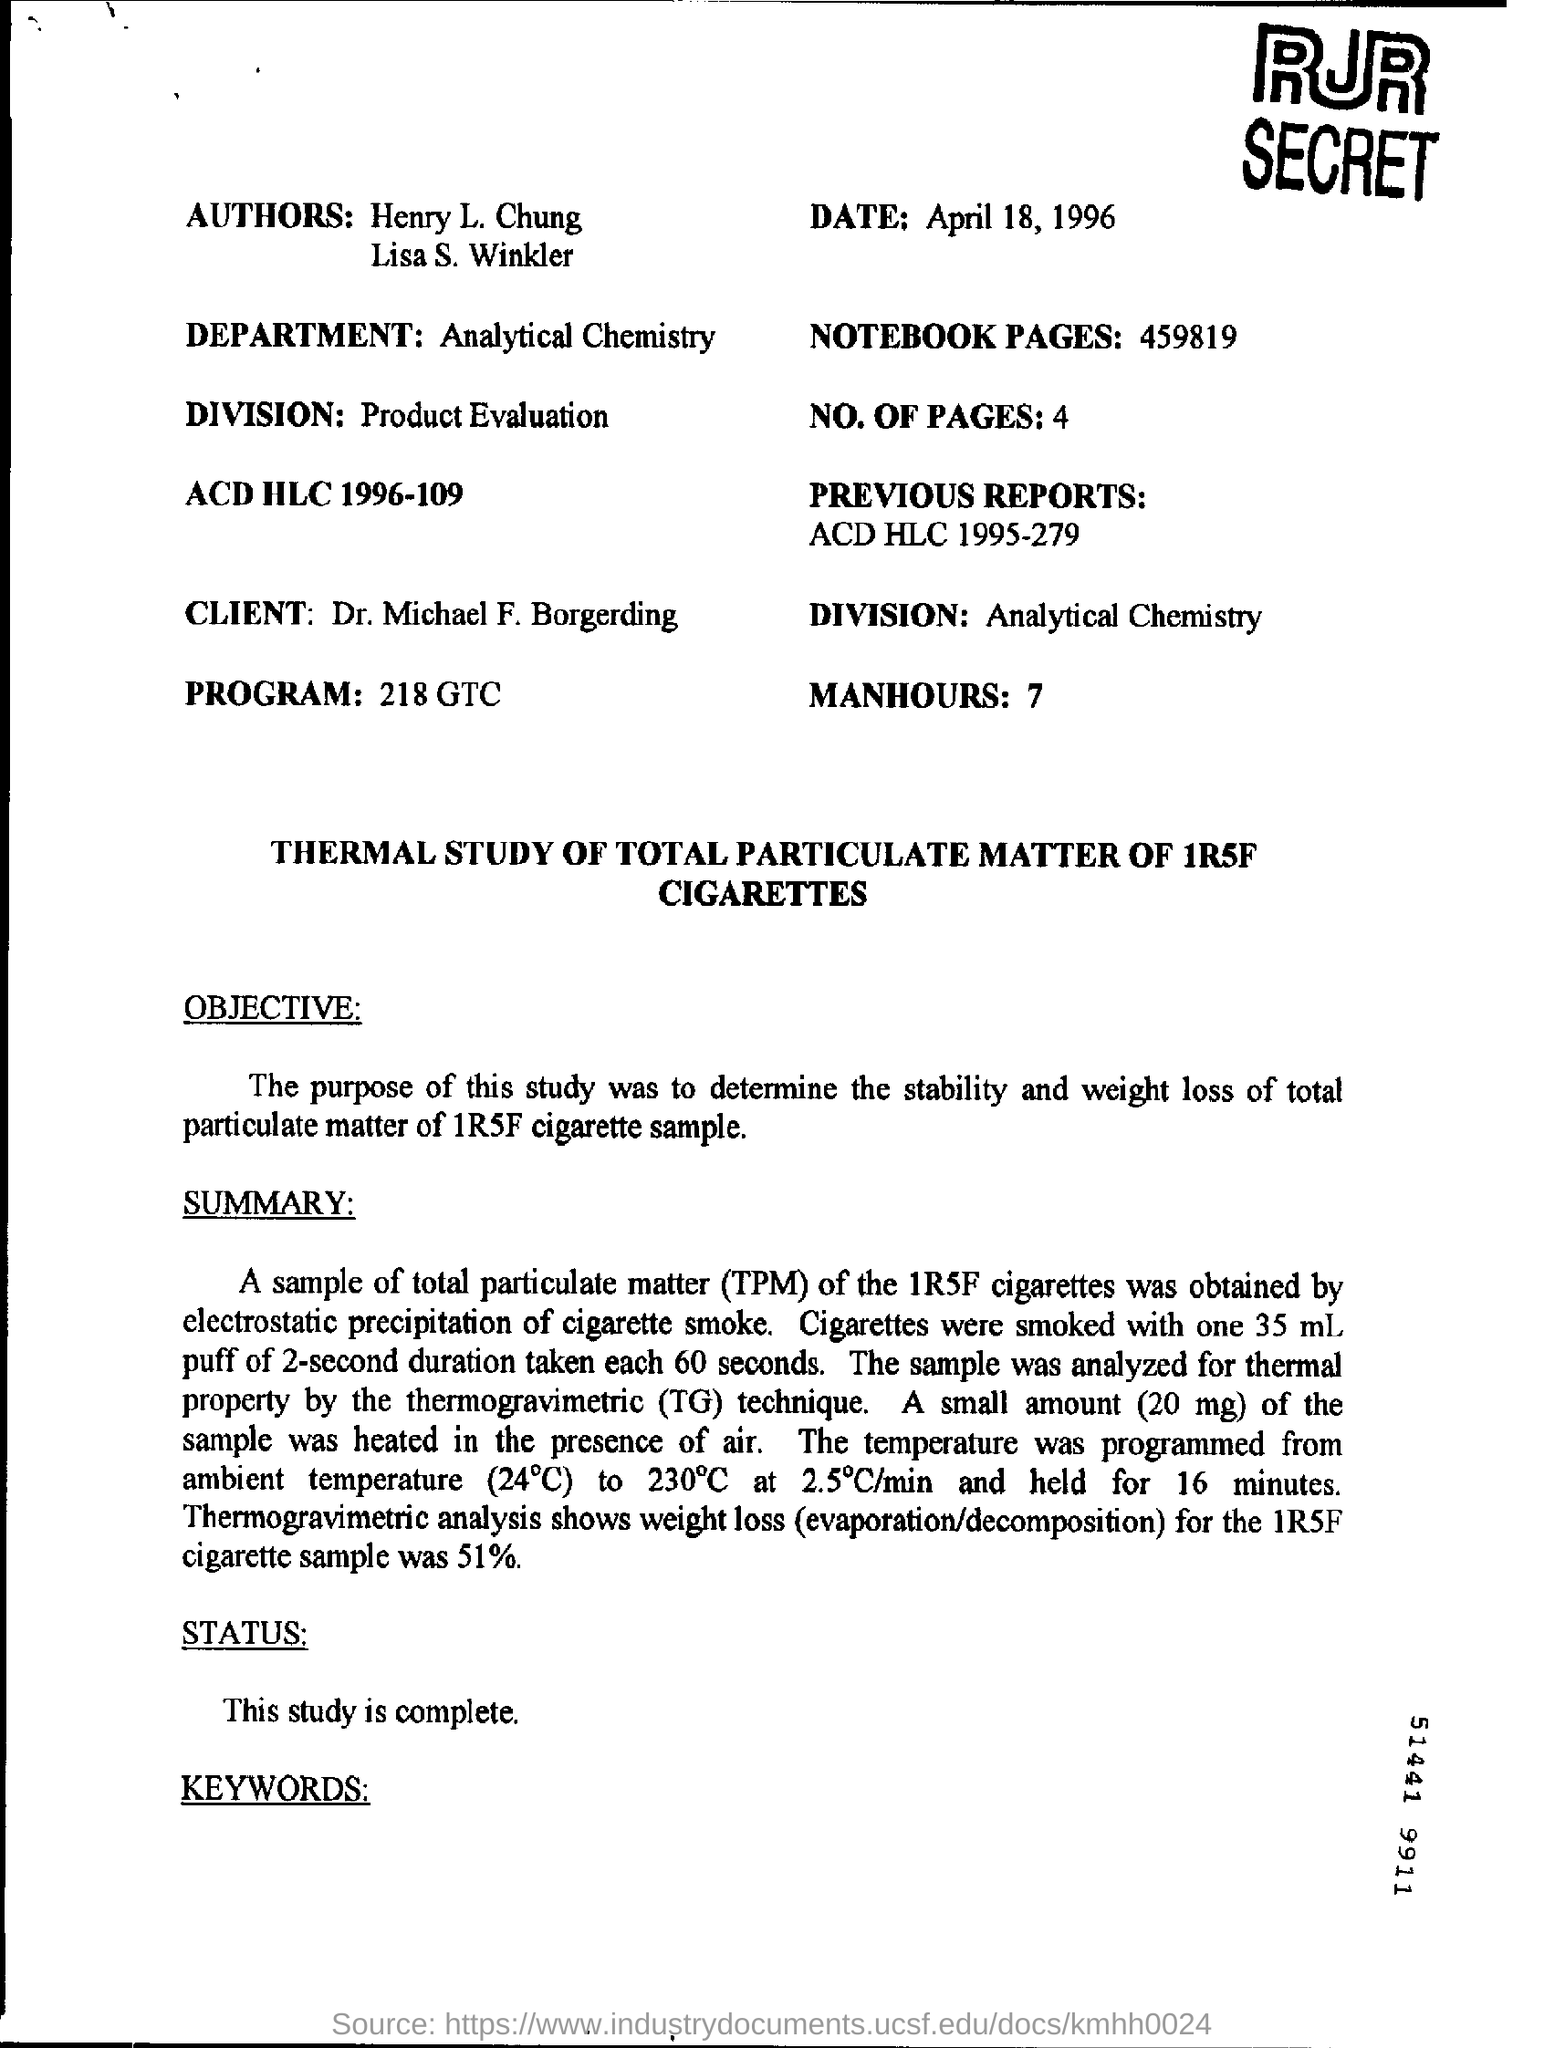Outline some significant characteristics in this image. Analytical Chemistry is mentioned in the department. The authors of this text are Henry L. Chung and Lisa S. Winkler. The thermal property of the sample was analyzed using the thermogravimetric (TG) technique. Total particulate matter, or TPM, refers to the combined concentration of all particles in the air. The date given is April 18, 1996. 